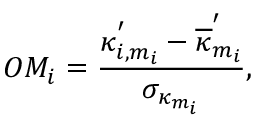Convert formula to latex. <formula><loc_0><loc_0><loc_500><loc_500>O M _ { i } = \frac { \kappa _ { i , m _ { i } } ^ { ^ { \prime } } - \overline { \kappa } _ { m _ { i } } ^ { ^ { \prime } } } { \sigma _ { \kappa _ { m _ { i } } } } ,</formula> 